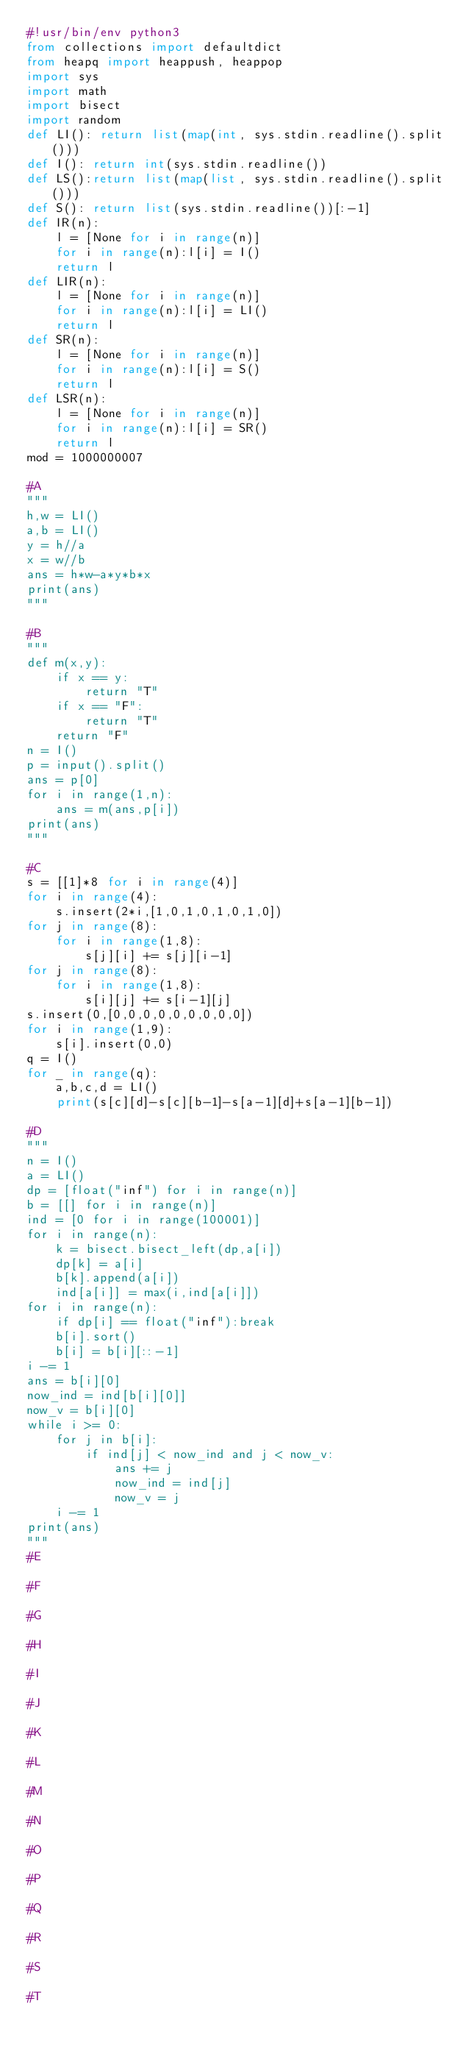<code> <loc_0><loc_0><loc_500><loc_500><_Python_>#!usr/bin/env python3
from collections import defaultdict
from heapq import heappush, heappop
import sys
import math
import bisect
import random
def LI(): return list(map(int, sys.stdin.readline().split()))
def I(): return int(sys.stdin.readline())
def LS():return list(map(list, sys.stdin.readline().split()))
def S(): return list(sys.stdin.readline())[:-1]
def IR(n):
    l = [None for i in range(n)]
    for i in range(n):l[i] = I()
    return l
def LIR(n):
    l = [None for i in range(n)]
    for i in range(n):l[i] = LI()
    return l
def SR(n):
    l = [None for i in range(n)]
    for i in range(n):l[i] = S()
    return l
def LSR(n):
    l = [None for i in range(n)]
    for i in range(n):l[i] = SR()
    return l
mod = 1000000007

#A
"""
h,w = LI()
a,b = LI()
y = h//a
x = w//b
ans = h*w-a*y*b*x
print(ans)
"""

#B
"""
def m(x,y):
    if x == y:
        return "T"
    if x == "F":
        return "T"
    return "F"
n = I()
p = input().split()
ans = p[0]
for i in range(1,n):
    ans = m(ans,p[i])
print(ans)
"""

#C
s = [[1]*8 for i in range(4)]
for i in range(4):
    s.insert(2*i,[1,0,1,0,1,0,1,0])
for j in range(8):
    for i in range(1,8):
        s[j][i] += s[j][i-1]
for j in range(8):
    for i in range(1,8):
        s[i][j] += s[i-1][j]
s.insert(0,[0,0,0,0,0,0,0,0,0])
for i in range(1,9):
    s[i].insert(0,0)
q = I()
for _ in range(q):
    a,b,c,d = LI()
    print(s[c][d]-s[c][b-1]-s[a-1][d]+s[a-1][b-1])

#D
"""
n = I()
a = LI()
dp = [float("inf") for i in range(n)]
b = [[] for i in range(n)]
ind = [0 for i in range(100001)]
for i in range(n):
    k = bisect.bisect_left(dp,a[i])
    dp[k] = a[i]
    b[k].append(a[i])
    ind[a[i]] = max(i,ind[a[i]])
for i in range(n):
    if dp[i] == float("inf"):break
    b[i].sort()
    b[i] = b[i][::-1]
i -= 1
ans = b[i][0]
now_ind = ind[b[i][0]]
now_v = b[i][0]
while i >= 0:
    for j in b[i]:
        if ind[j] < now_ind and j < now_v:
            ans += j
            now_ind = ind[j]
            now_v = j
    i -= 1
print(ans)
"""
#E

#F

#G

#H

#I

#J

#K

#L

#M

#N

#O

#P

#Q

#R

#S

#T

</code> 